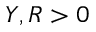Convert formula to latex. <formula><loc_0><loc_0><loc_500><loc_500>Y , R > 0</formula> 